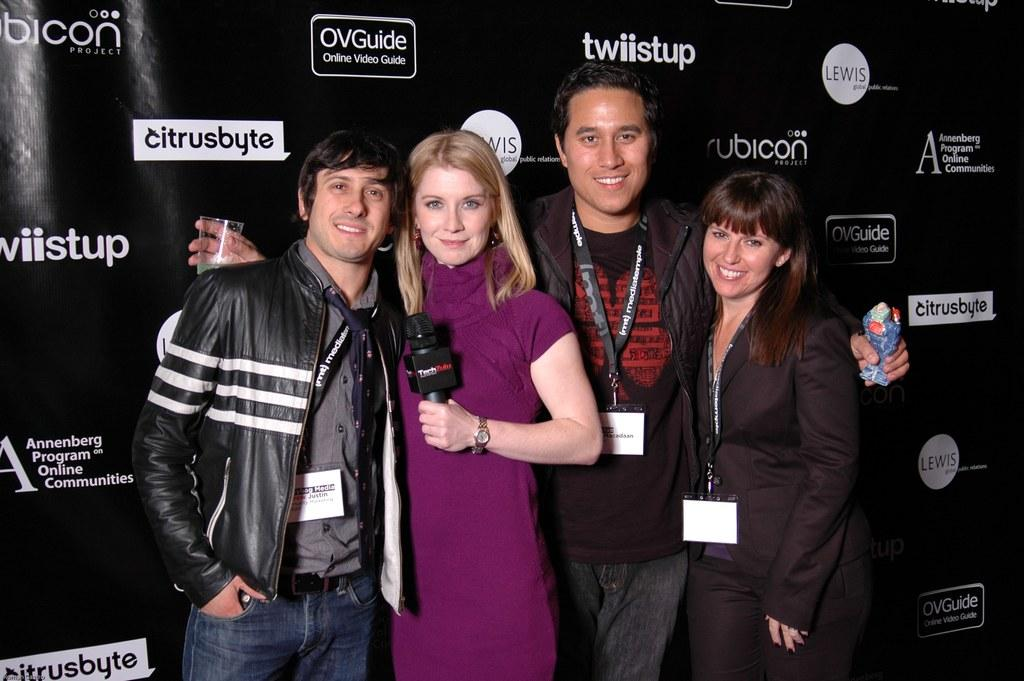<image>
Offer a succinct explanation of the picture presented. A woman with a microphone is standing with three other people in front of a wall covered with product names including rubicon. 